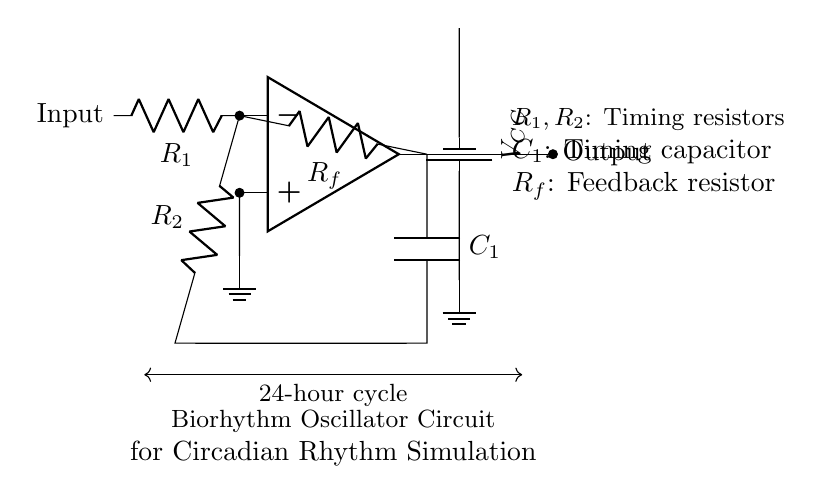What components are used in the oscillator circuit? The circuit contains an operational amplifier, two resistors (R1 and R2), a feedback resistor (Rf), and a capacitor (C1). Each component contributes to the timing and feedback mechanism in the oscillator.
Answer: operational amplifier, resistors, capacitor What is the role of the feedback resistor (Rf)? The feedback resistor connects the output of the operational amplifier back to its inverting input, creating a feedback loop essential for oscillator operation by controlling gain and stability.
Answer: feedback control How many timing components are present in the circuit? The timing elements include two resistors (R1 and R2) and one capacitor (C1), which determine the frequency of oscillation.
Answer: three What is the significance of the 24-hour cycle indicated in the diagram? The 24-hour cycle represents the intended output of the oscillator, which is designed to simulate circadian rhythms typical of human sleep-wake cycles over a full day.
Answer: circadian rhythms How does the operational amplifier contribute to the oscillation? The operational amplifier amplifies the input signal and, through the configuration of resistors and capacitor, creates a continuous feedback loop that generates periodic oscillations, thus simulating rhythms.
Answer: generates oscillations How do R1 and C1 interact to set the timing of the oscillator? R1 and C1 form an RC time constant, which dictates the charge and discharge cycles, ultimately controlling the frequency of the oscillation according to the formula f = 1/(2πRC).
Answer: timing control What is the purpose of the battery in the circuit? The battery provides the necessary power supply (VCC) for the operational amplifier and other active components, ensuring they function correctly within the circuit.
Answer: power supply 